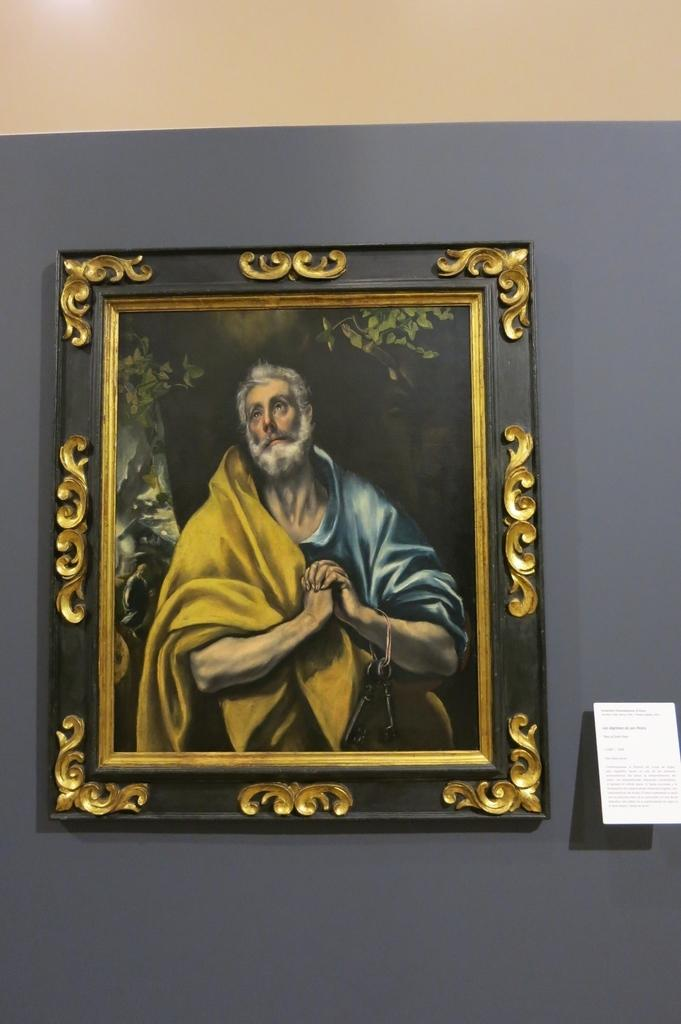What is depicted in the image? There is a painting in the image. What is the subject of the painting? The painting is of a person. Where is the painting located in the image? The painting is attached to the wall. Who is the painting's partner in the image? There is no partner present in the image, as the painting is the main subject. 